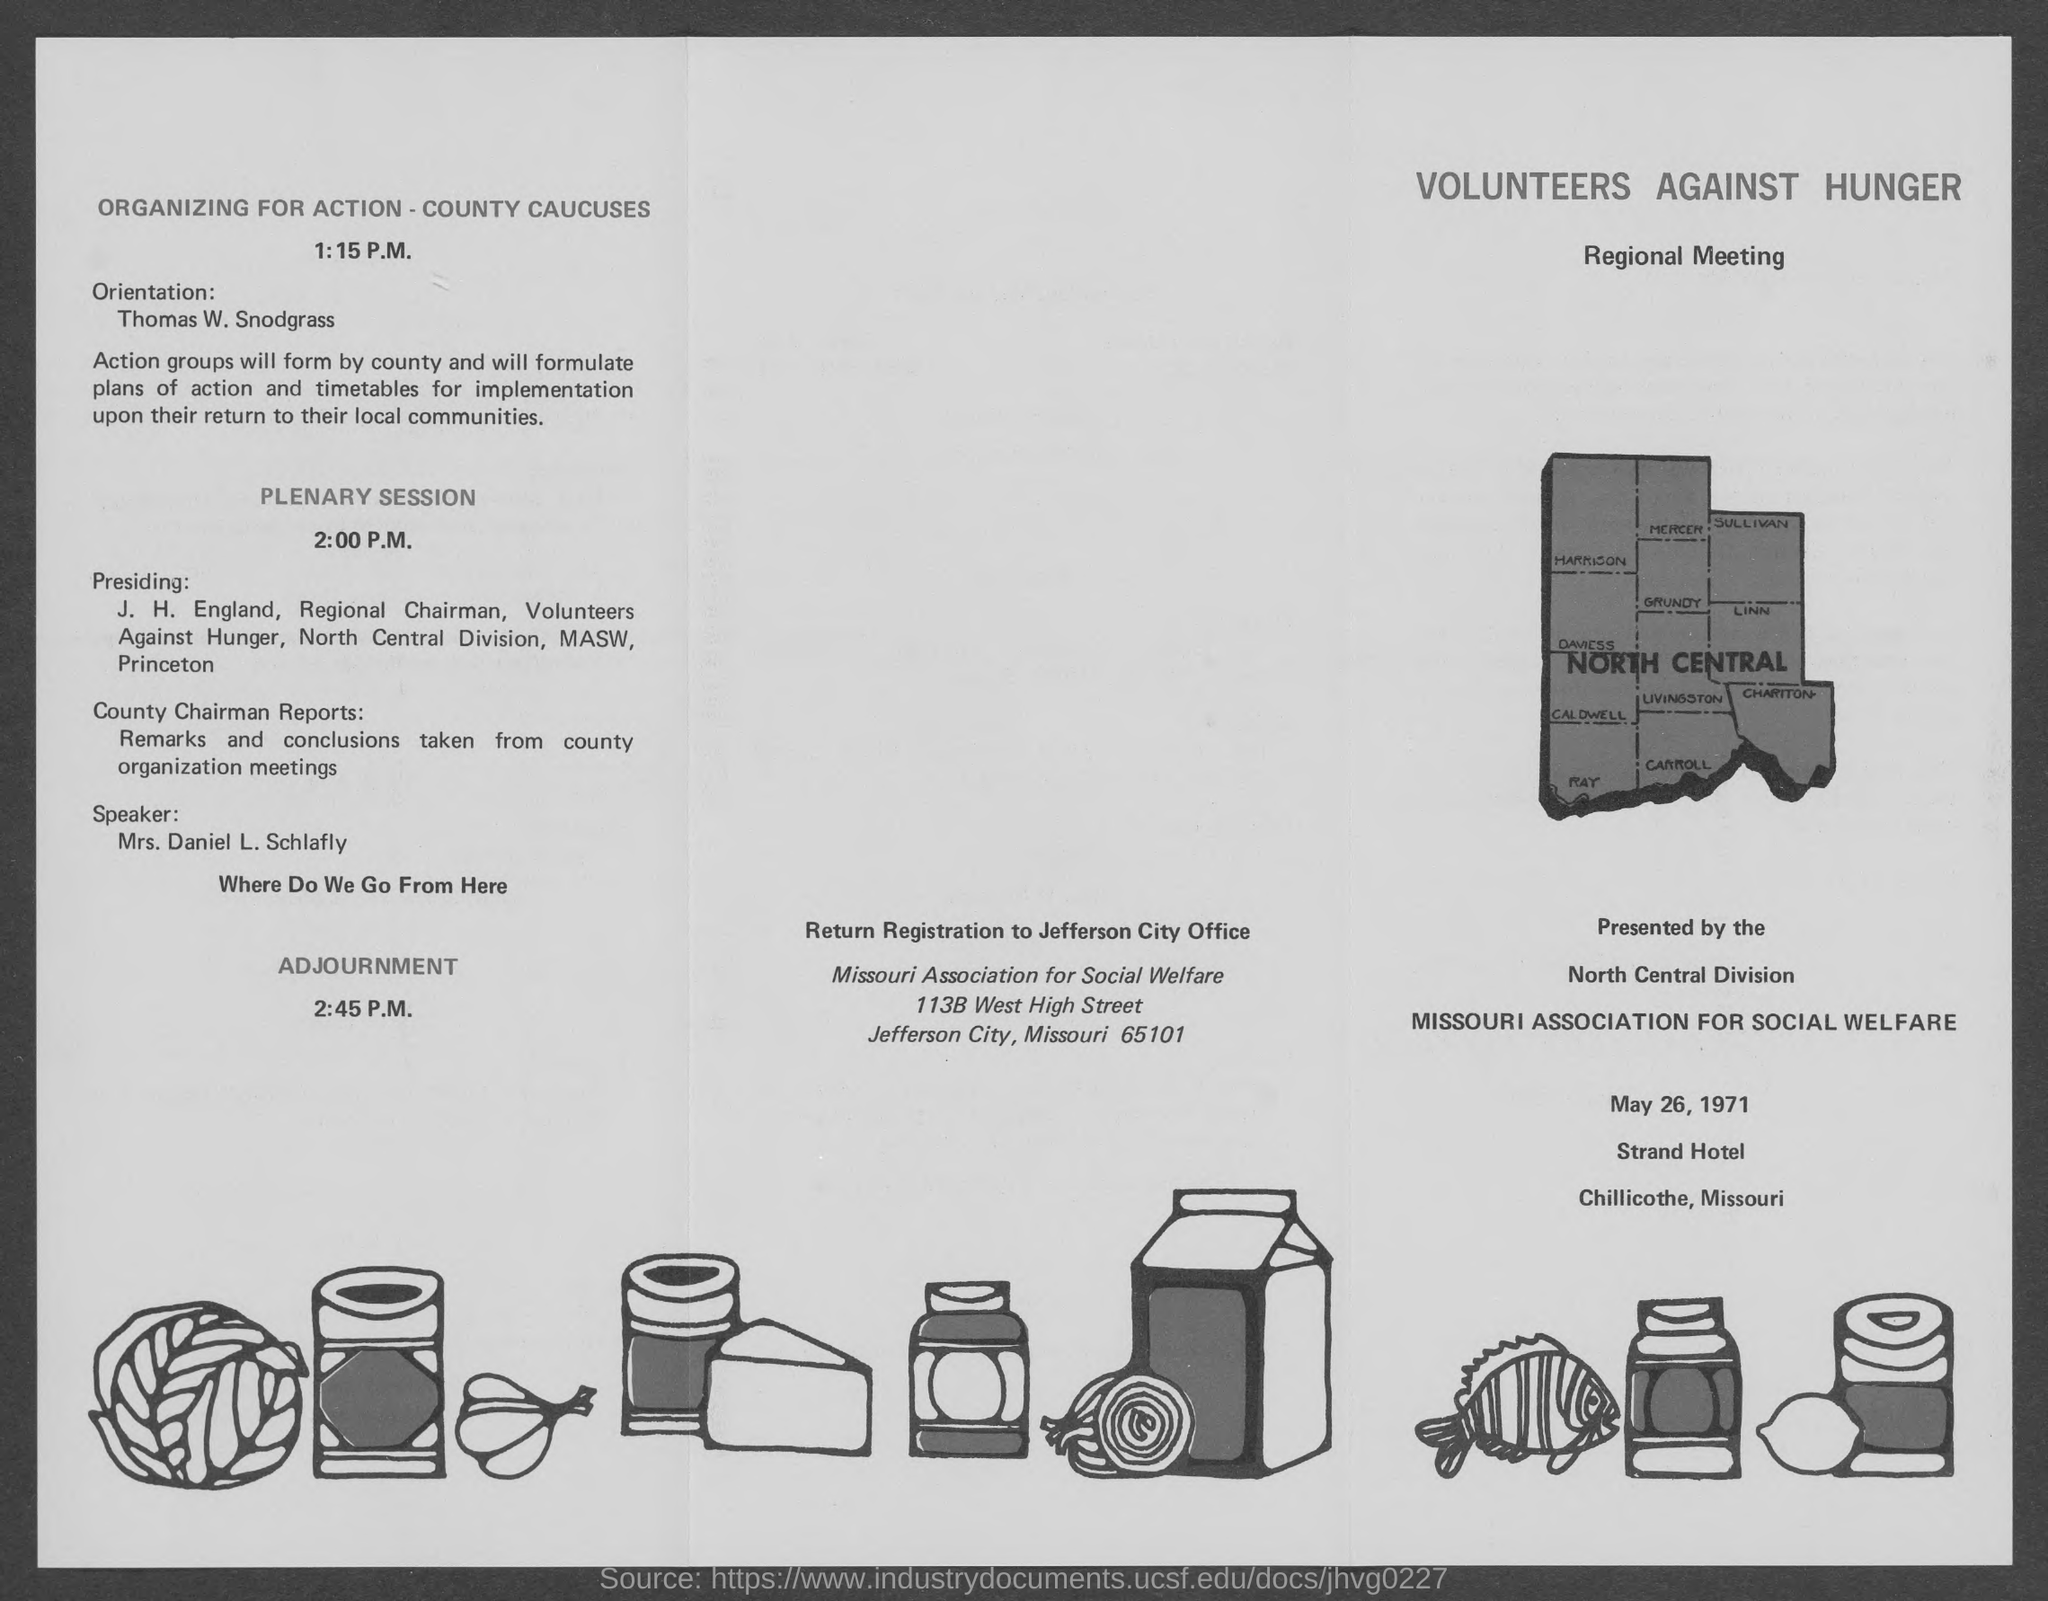Where should registration be returned?
Keep it short and to the point. Jefferson City Office. When is the regional meeting going to be held?
Your response must be concise. May 26, 1971. By whom is the orientation?
Give a very brief answer. Thomas W. Snodgrass. At what time is the plenary session?
Your answer should be compact. 2:00 P.M. Who is presiding?
Make the answer very short. J. H. England, Regional Chairman. Who is the speaker for the plenary session?
Offer a very short reply. Mrs. Daniel L. Schlafly. What is the topic of Mrs. Daniel?
Give a very brief answer. Where Do We Go From Here. 